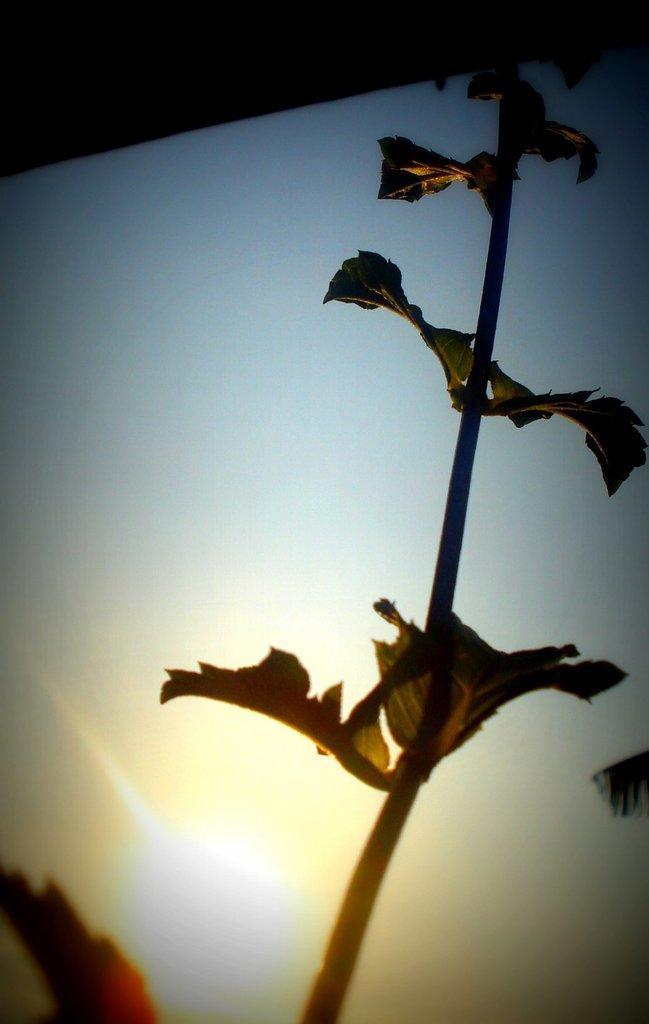What type of living organism can be seen in the image? There is a plant in the image. What part of the natural environment is visible in the image? The sky is visible in the image. Can the sun be seen in the image? Yes, the sun is observable in the image. What is the color of the object at the top of the image? The object at the top of the image is black. What type of peace symbol is present in the image? There is no peace symbol present in the image. What type of boundary is depicted in the image? There is no boundary depicted in the image. What type of sweater is being worn by the plant in the image? Plants do not wear sweaters, and there is no person or animal present in the image. 